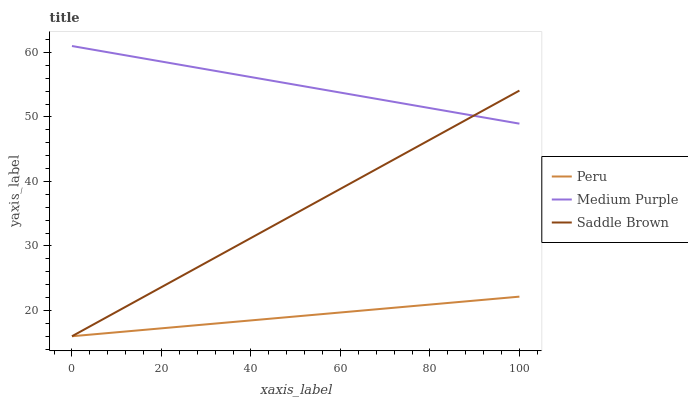Does Peru have the minimum area under the curve?
Answer yes or no. Yes. Does Medium Purple have the maximum area under the curve?
Answer yes or no. Yes. Does Saddle Brown have the minimum area under the curve?
Answer yes or no. No. Does Saddle Brown have the maximum area under the curve?
Answer yes or no. No. Is Peru the smoothest?
Answer yes or no. Yes. Is Medium Purple the roughest?
Answer yes or no. Yes. Is Saddle Brown the smoothest?
Answer yes or no. No. Is Saddle Brown the roughest?
Answer yes or no. No. Does Saddle Brown have the lowest value?
Answer yes or no. Yes. Does Medium Purple have the highest value?
Answer yes or no. Yes. Does Saddle Brown have the highest value?
Answer yes or no. No. Is Peru less than Medium Purple?
Answer yes or no. Yes. Is Medium Purple greater than Peru?
Answer yes or no. Yes. Does Saddle Brown intersect Peru?
Answer yes or no. Yes. Is Saddle Brown less than Peru?
Answer yes or no. No. Is Saddle Brown greater than Peru?
Answer yes or no. No. Does Peru intersect Medium Purple?
Answer yes or no. No. 